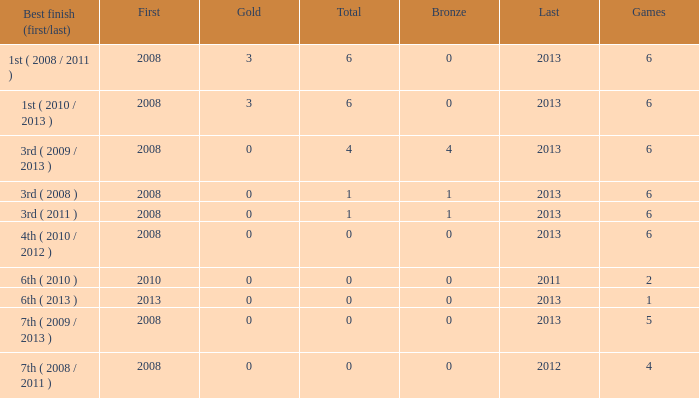How many games are associated with over 0 golds and a first year before 2008? None. 